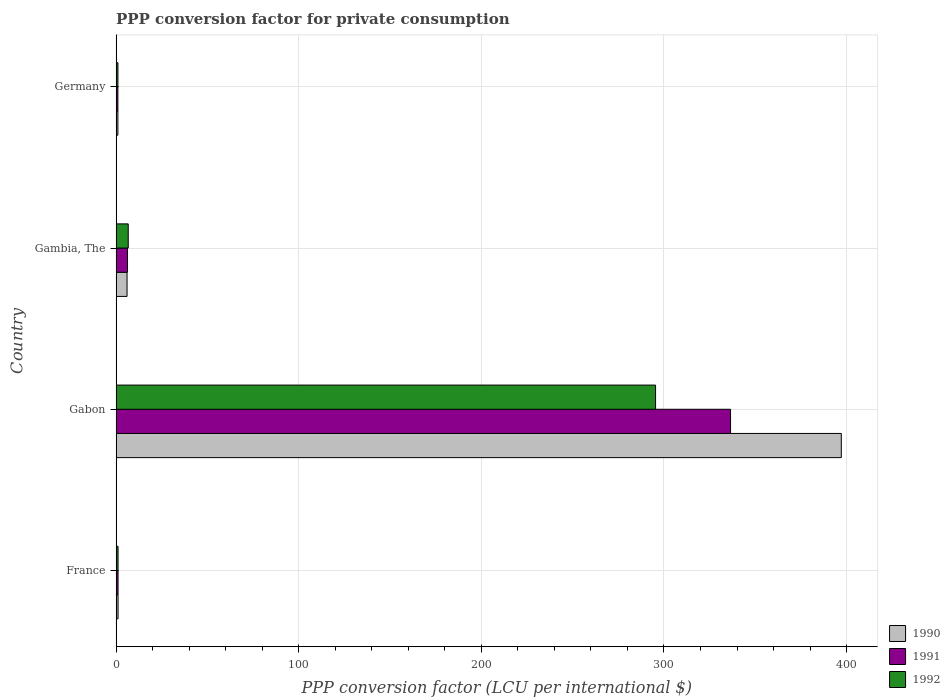Are the number of bars per tick equal to the number of legend labels?
Offer a very short reply. Yes. Are the number of bars on each tick of the Y-axis equal?
Provide a short and direct response. Yes. How many bars are there on the 3rd tick from the bottom?
Keep it short and to the point. 3. What is the label of the 2nd group of bars from the top?
Your answer should be compact. Gambia, The. What is the PPP conversion factor for private consumption in 1992 in Germany?
Provide a succinct answer. 0.98. Across all countries, what is the maximum PPP conversion factor for private consumption in 1991?
Provide a short and direct response. 336.44. Across all countries, what is the minimum PPP conversion factor for private consumption in 1990?
Your answer should be compact. 0.96. In which country was the PPP conversion factor for private consumption in 1992 maximum?
Your answer should be compact. Gabon. In which country was the PPP conversion factor for private consumption in 1991 minimum?
Make the answer very short. Germany. What is the total PPP conversion factor for private consumption in 1992 in the graph?
Provide a succinct answer. 304.04. What is the difference between the PPP conversion factor for private consumption in 1990 in France and that in Germany?
Keep it short and to the point. 0.09. What is the difference between the PPP conversion factor for private consumption in 1992 in Gabon and the PPP conversion factor for private consumption in 1990 in Germany?
Ensure brevity in your answer.  294.43. What is the average PPP conversion factor for private consumption in 1991 per country?
Provide a short and direct response. 86.17. What is the difference between the PPP conversion factor for private consumption in 1992 and PPP conversion factor for private consumption in 1991 in Gabon?
Ensure brevity in your answer.  -41.05. In how many countries, is the PPP conversion factor for private consumption in 1990 greater than 180 LCU?
Provide a short and direct response. 1. What is the ratio of the PPP conversion factor for private consumption in 1990 in France to that in Gabon?
Keep it short and to the point. 0. Is the PPP conversion factor for private consumption in 1992 in France less than that in Germany?
Offer a very short reply. No. Is the difference between the PPP conversion factor for private consumption in 1992 in Gambia, The and Germany greater than the difference between the PPP conversion factor for private consumption in 1991 in Gambia, The and Germany?
Your answer should be compact. Yes. What is the difference between the highest and the second highest PPP conversion factor for private consumption in 1991?
Offer a terse response. 330.21. What is the difference between the highest and the lowest PPP conversion factor for private consumption in 1992?
Make the answer very short. 294.41. Is the sum of the PPP conversion factor for private consumption in 1992 in France and Germany greater than the maximum PPP conversion factor for private consumption in 1991 across all countries?
Offer a very short reply. No. How many countries are there in the graph?
Make the answer very short. 4. What is the difference between two consecutive major ticks on the X-axis?
Keep it short and to the point. 100. Are the values on the major ticks of X-axis written in scientific E-notation?
Provide a short and direct response. No. How are the legend labels stacked?
Provide a succinct answer. Vertical. What is the title of the graph?
Make the answer very short. PPP conversion factor for private consumption. Does "2005" appear as one of the legend labels in the graph?
Provide a succinct answer. No. What is the label or title of the X-axis?
Give a very brief answer. PPP conversion factor (LCU per international $). What is the label or title of the Y-axis?
Provide a short and direct response. Country. What is the PPP conversion factor (LCU per international $) of 1990 in France?
Give a very brief answer. 1.06. What is the PPP conversion factor (LCU per international $) of 1991 in France?
Provide a short and direct response. 1.05. What is the PPP conversion factor (LCU per international $) in 1992 in France?
Provide a succinct answer. 1.05. What is the PPP conversion factor (LCU per international $) of 1990 in Gabon?
Your answer should be compact. 397.1. What is the PPP conversion factor (LCU per international $) of 1991 in Gabon?
Your response must be concise. 336.44. What is the PPP conversion factor (LCU per international $) in 1992 in Gabon?
Ensure brevity in your answer.  295.39. What is the PPP conversion factor (LCU per international $) of 1990 in Gambia, The?
Provide a succinct answer. 5.98. What is the PPP conversion factor (LCU per international $) in 1991 in Gambia, The?
Provide a short and direct response. 6.23. What is the PPP conversion factor (LCU per international $) of 1992 in Gambia, The?
Ensure brevity in your answer.  6.62. What is the PPP conversion factor (LCU per international $) of 1990 in Germany?
Offer a very short reply. 0.96. What is the PPP conversion factor (LCU per international $) in 1991 in Germany?
Ensure brevity in your answer.  0.96. What is the PPP conversion factor (LCU per international $) of 1992 in Germany?
Your answer should be very brief. 0.98. Across all countries, what is the maximum PPP conversion factor (LCU per international $) of 1990?
Your response must be concise. 397.1. Across all countries, what is the maximum PPP conversion factor (LCU per international $) of 1991?
Provide a short and direct response. 336.44. Across all countries, what is the maximum PPP conversion factor (LCU per international $) in 1992?
Provide a succinct answer. 295.39. Across all countries, what is the minimum PPP conversion factor (LCU per international $) in 1990?
Ensure brevity in your answer.  0.96. Across all countries, what is the minimum PPP conversion factor (LCU per international $) in 1991?
Your answer should be compact. 0.96. Across all countries, what is the minimum PPP conversion factor (LCU per international $) in 1992?
Your response must be concise. 0.98. What is the total PPP conversion factor (LCU per international $) in 1990 in the graph?
Give a very brief answer. 405.1. What is the total PPP conversion factor (LCU per international $) in 1991 in the graph?
Provide a short and direct response. 344.69. What is the total PPP conversion factor (LCU per international $) of 1992 in the graph?
Provide a short and direct response. 304.04. What is the difference between the PPP conversion factor (LCU per international $) in 1990 in France and that in Gabon?
Offer a very short reply. -396.04. What is the difference between the PPP conversion factor (LCU per international $) of 1991 in France and that in Gabon?
Ensure brevity in your answer.  -335.39. What is the difference between the PPP conversion factor (LCU per international $) of 1992 in France and that in Gabon?
Your response must be concise. -294.34. What is the difference between the PPP conversion factor (LCU per international $) in 1990 in France and that in Gambia, The?
Provide a short and direct response. -4.93. What is the difference between the PPP conversion factor (LCU per international $) of 1991 in France and that in Gambia, The?
Ensure brevity in your answer.  -5.18. What is the difference between the PPP conversion factor (LCU per international $) of 1992 in France and that in Gambia, The?
Provide a short and direct response. -5.58. What is the difference between the PPP conversion factor (LCU per international $) of 1990 in France and that in Germany?
Offer a terse response. 0.09. What is the difference between the PPP conversion factor (LCU per international $) of 1991 in France and that in Germany?
Your response must be concise. 0.09. What is the difference between the PPP conversion factor (LCU per international $) in 1992 in France and that in Germany?
Provide a succinct answer. 0.07. What is the difference between the PPP conversion factor (LCU per international $) of 1990 in Gabon and that in Gambia, The?
Your answer should be very brief. 391.12. What is the difference between the PPP conversion factor (LCU per international $) of 1991 in Gabon and that in Gambia, The?
Provide a succinct answer. 330.21. What is the difference between the PPP conversion factor (LCU per international $) in 1992 in Gabon and that in Gambia, The?
Ensure brevity in your answer.  288.77. What is the difference between the PPP conversion factor (LCU per international $) in 1990 in Gabon and that in Germany?
Keep it short and to the point. 396.13. What is the difference between the PPP conversion factor (LCU per international $) of 1991 in Gabon and that in Germany?
Keep it short and to the point. 335.48. What is the difference between the PPP conversion factor (LCU per international $) of 1992 in Gabon and that in Germany?
Keep it short and to the point. 294.41. What is the difference between the PPP conversion factor (LCU per international $) in 1990 in Gambia, The and that in Germany?
Your answer should be compact. 5.02. What is the difference between the PPP conversion factor (LCU per international $) in 1991 in Gambia, The and that in Germany?
Ensure brevity in your answer.  5.27. What is the difference between the PPP conversion factor (LCU per international $) of 1992 in Gambia, The and that in Germany?
Your response must be concise. 5.65. What is the difference between the PPP conversion factor (LCU per international $) in 1990 in France and the PPP conversion factor (LCU per international $) in 1991 in Gabon?
Keep it short and to the point. -335.39. What is the difference between the PPP conversion factor (LCU per international $) of 1990 in France and the PPP conversion factor (LCU per international $) of 1992 in Gabon?
Give a very brief answer. -294.33. What is the difference between the PPP conversion factor (LCU per international $) of 1991 in France and the PPP conversion factor (LCU per international $) of 1992 in Gabon?
Your response must be concise. -294.34. What is the difference between the PPP conversion factor (LCU per international $) in 1990 in France and the PPP conversion factor (LCU per international $) in 1991 in Gambia, The?
Your answer should be very brief. -5.18. What is the difference between the PPP conversion factor (LCU per international $) of 1990 in France and the PPP conversion factor (LCU per international $) of 1992 in Gambia, The?
Your answer should be compact. -5.57. What is the difference between the PPP conversion factor (LCU per international $) of 1991 in France and the PPP conversion factor (LCU per international $) of 1992 in Gambia, The?
Offer a terse response. -5.58. What is the difference between the PPP conversion factor (LCU per international $) in 1990 in France and the PPP conversion factor (LCU per international $) in 1991 in Germany?
Your response must be concise. 0.09. What is the difference between the PPP conversion factor (LCU per international $) of 1990 in France and the PPP conversion factor (LCU per international $) of 1992 in Germany?
Make the answer very short. 0.08. What is the difference between the PPP conversion factor (LCU per international $) of 1991 in France and the PPP conversion factor (LCU per international $) of 1992 in Germany?
Offer a terse response. 0.07. What is the difference between the PPP conversion factor (LCU per international $) in 1990 in Gabon and the PPP conversion factor (LCU per international $) in 1991 in Gambia, The?
Ensure brevity in your answer.  390.86. What is the difference between the PPP conversion factor (LCU per international $) in 1990 in Gabon and the PPP conversion factor (LCU per international $) in 1992 in Gambia, The?
Provide a succinct answer. 390.47. What is the difference between the PPP conversion factor (LCU per international $) in 1991 in Gabon and the PPP conversion factor (LCU per international $) in 1992 in Gambia, The?
Provide a succinct answer. 329.82. What is the difference between the PPP conversion factor (LCU per international $) of 1990 in Gabon and the PPP conversion factor (LCU per international $) of 1991 in Germany?
Your answer should be compact. 396.13. What is the difference between the PPP conversion factor (LCU per international $) in 1990 in Gabon and the PPP conversion factor (LCU per international $) in 1992 in Germany?
Offer a very short reply. 396.12. What is the difference between the PPP conversion factor (LCU per international $) of 1991 in Gabon and the PPP conversion factor (LCU per international $) of 1992 in Germany?
Ensure brevity in your answer.  335.47. What is the difference between the PPP conversion factor (LCU per international $) of 1990 in Gambia, The and the PPP conversion factor (LCU per international $) of 1991 in Germany?
Offer a terse response. 5.02. What is the difference between the PPP conversion factor (LCU per international $) in 1990 in Gambia, The and the PPP conversion factor (LCU per international $) in 1992 in Germany?
Your response must be concise. 5. What is the difference between the PPP conversion factor (LCU per international $) of 1991 in Gambia, The and the PPP conversion factor (LCU per international $) of 1992 in Germany?
Provide a short and direct response. 5.26. What is the average PPP conversion factor (LCU per international $) of 1990 per country?
Make the answer very short. 101.27. What is the average PPP conversion factor (LCU per international $) in 1991 per country?
Your answer should be compact. 86.17. What is the average PPP conversion factor (LCU per international $) in 1992 per country?
Ensure brevity in your answer.  76.01. What is the difference between the PPP conversion factor (LCU per international $) of 1990 and PPP conversion factor (LCU per international $) of 1991 in France?
Provide a short and direct response. 0.01. What is the difference between the PPP conversion factor (LCU per international $) in 1990 and PPP conversion factor (LCU per international $) in 1992 in France?
Offer a very short reply. 0.01. What is the difference between the PPP conversion factor (LCU per international $) of 1991 and PPP conversion factor (LCU per international $) of 1992 in France?
Keep it short and to the point. 0. What is the difference between the PPP conversion factor (LCU per international $) in 1990 and PPP conversion factor (LCU per international $) in 1991 in Gabon?
Your answer should be very brief. 60.65. What is the difference between the PPP conversion factor (LCU per international $) of 1990 and PPP conversion factor (LCU per international $) of 1992 in Gabon?
Offer a terse response. 101.71. What is the difference between the PPP conversion factor (LCU per international $) of 1991 and PPP conversion factor (LCU per international $) of 1992 in Gabon?
Ensure brevity in your answer.  41.05. What is the difference between the PPP conversion factor (LCU per international $) of 1990 and PPP conversion factor (LCU per international $) of 1991 in Gambia, The?
Provide a succinct answer. -0.25. What is the difference between the PPP conversion factor (LCU per international $) of 1990 and PPP conversion factor (LCU per international $) of 1992 in Gambia, The?
Keep it short and to the point. -0.64. What is the difference between the PPP conversion factor (LCU per international $) in 1991 and PPP conversion factor (LCU per international $) in 1992 in Gambia, The?
Your answer should be compact. -0.39. What is the difference between the PPP conversion factor (LCU per international $) in 1990 and PPP conversion factor (LCU per international $) in 1992 in Germany?
Your answer should be compact. -0.01. What is the difference between the PPP conversion factor (LCU per international $) in 1991 and PPP conversion factor (LCU per international $) in 1992 in Germany?
Offer a terse response. -0.01. What is the ratio of the PPP conversion factor (LCU per international $) of 1990 in France to that in Gabon?
Your response must be concise. 0. What is the ratio of the PPP conversion factor (LCU per international $) in 1991 in France to that in Gabon?
Give a very brief answer. 0. What is the ratio of the PPP conversion factor (LCU per international $) in 1992 in France to that in Gabon?
Keep it short and to the point. 0. What is the ratio of the PPP conversion factor (LCU per international $) of 1990 in France to that in Gambia, The?
Offer a terse response. 0.18. What is the ratio of the PPP conversion factor (LCU per international $) of 1991 in France to that in Gambia, The?
Your response must be concise. 0.17. What is the ratio of the PPP conversion factor (LCU per international $) of 1992 in France to that in Gambia, The?
Offer a terse response. 0.16. What is the ratio of the PPP conversion factor (LCU per international $) of 1990 in France to that in Germany?
Your answer should be very brief. 1.1. What is the ratio of the PPP conversion factor (LCU per international $) of 1991 in France to that in Germany?
Make the answer very short. 1.09. What is the ratio of the PPP conversion factor (LCU per international $) of 1992 in France to that in Germany?
Your response must be concise. 1.07. What is the ratio of the PPP conversion factor (LCU per international $) of 1990 in Gabon to that in Gambia, The?
Ensure brevity in your answer.  66.39. What is the ratio of the PPP conversion factor (LCU per international $) of 1991 in Gabon to that in Gambia, The?
Your answer should be compact. 53.97. What is the ratio of the PPP conversion factor (LCU per international $) of 1992 in Gabon to that in Gambia, The?
Provide a succinct answer. 44.59. What is the ratio of the PPP conversion factor (LCU per international $) in 1990 in Gabon to that in Germany?
Offer a terse response. 411.93. What is the ratio of the PPP conversion factor (LCU per international $) in 1991 in Gabon to that in Germany?
Offer a terse response. 349.1. What is the ratio of the PPP conversion factor (LCU per international $) in 1992 in Gabon to that in Germany?
Offer a terse response. 301.98. What is the ratio of the PPP conversion factor (LCU per international $) in 1990 in Gambia, The to that in Germany?
Provide a succinct answer. 6.2. What is the ratio of the PPP conversion factor (LCU per international $) of 1991 in Gambia, The to that in Germany?
Make the answer very short. 6.47. What is the ratio of the PPP conversion factor (LCU per international $) of 1992 in Gambia, The to that in Germany?
Give a very brief answer. 6.77. What is the difference between the highest and the second highest PPP conversion factor (LCU per international $) of 1990?
Offer a terse response. 391.12. What is the difference between the highest and the second highest PPP conversion factor (LCU per international $) in 1991?
Provide a short and direct response. 330.21. What is the difference between the highest and the second highest PPP conversion factor (LCU per international $) of 1992?
Provide a succinct answer. 288.77. What is the difference between the highest and the lowest PPP conversion factor (LCU per international $) in 1990?
Your answer should be compact. 396.13. What is the difference between the highest and the lowest PPP conversion factor (LCU per international $) of 1991?
Provide a short and direct response. 335.48. What is the difference between the highest and the lowest PPP conversion factor (LCU per international $) of 1992?
Offer a very short reply. 294.41. 